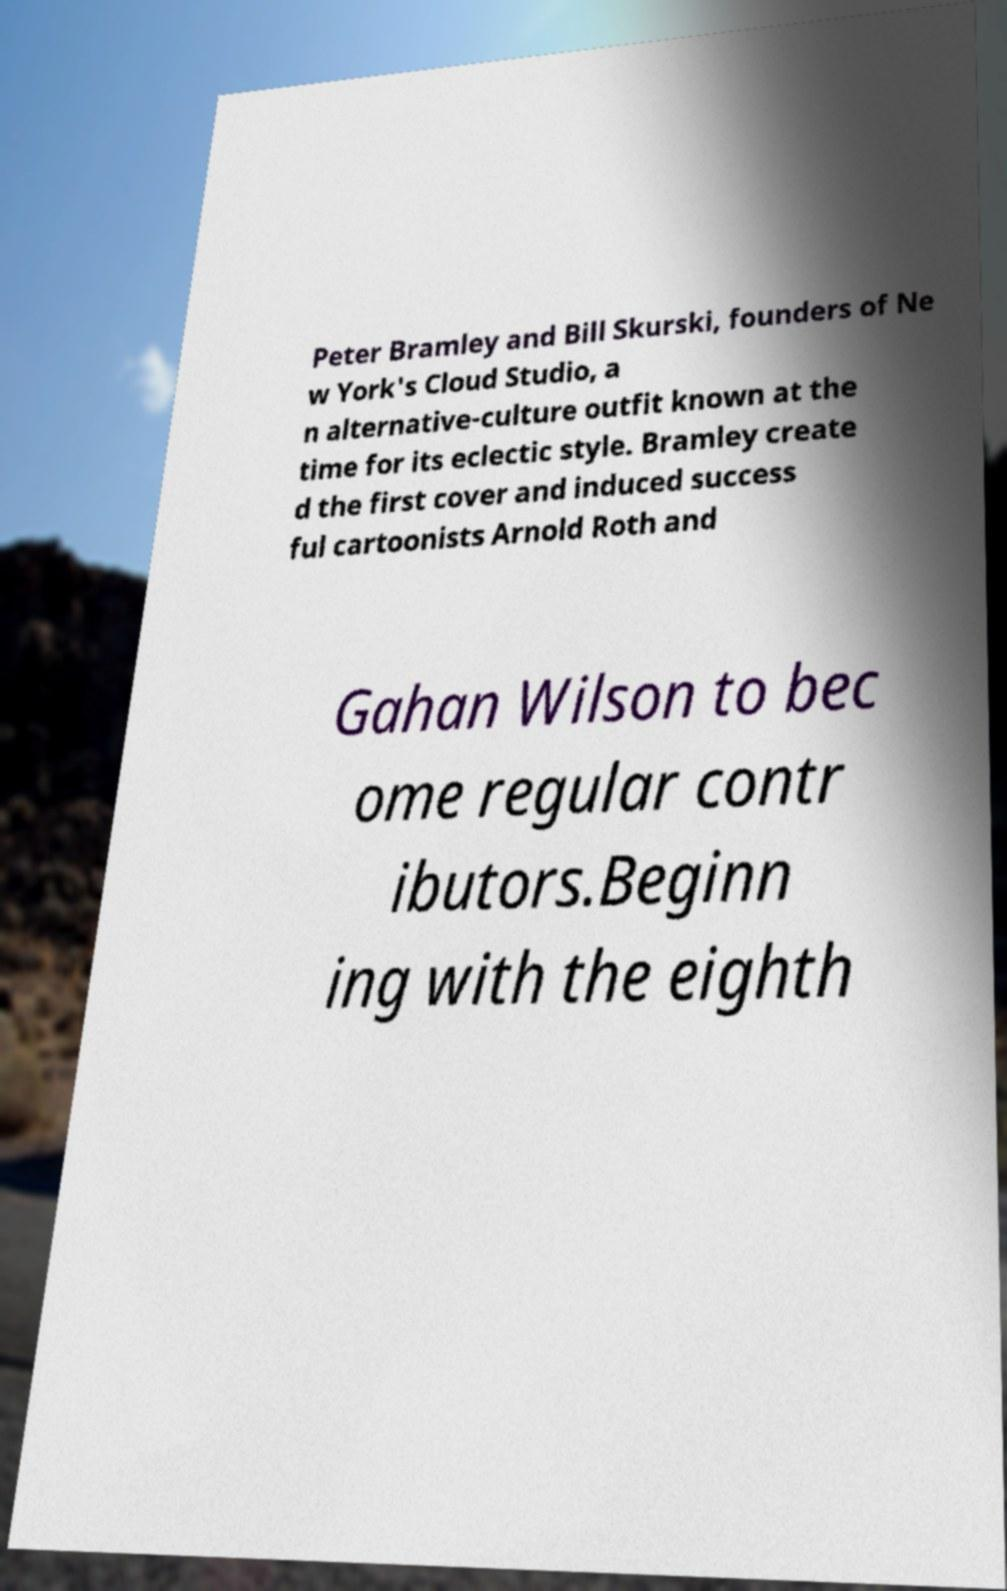Please read and relay the text visible in this image. What does it say? Peter Bramley and Bill Skurski, founders of Ne w York's Cloud Studio, a n alternative-culture outfit known at the time for its eclectic style. Bramley create d the first cover and induced success ful cartoonists Arnold Roth and Gahan Wilson to bec ome regular contr ibutors.Beginn ing with the eighth 